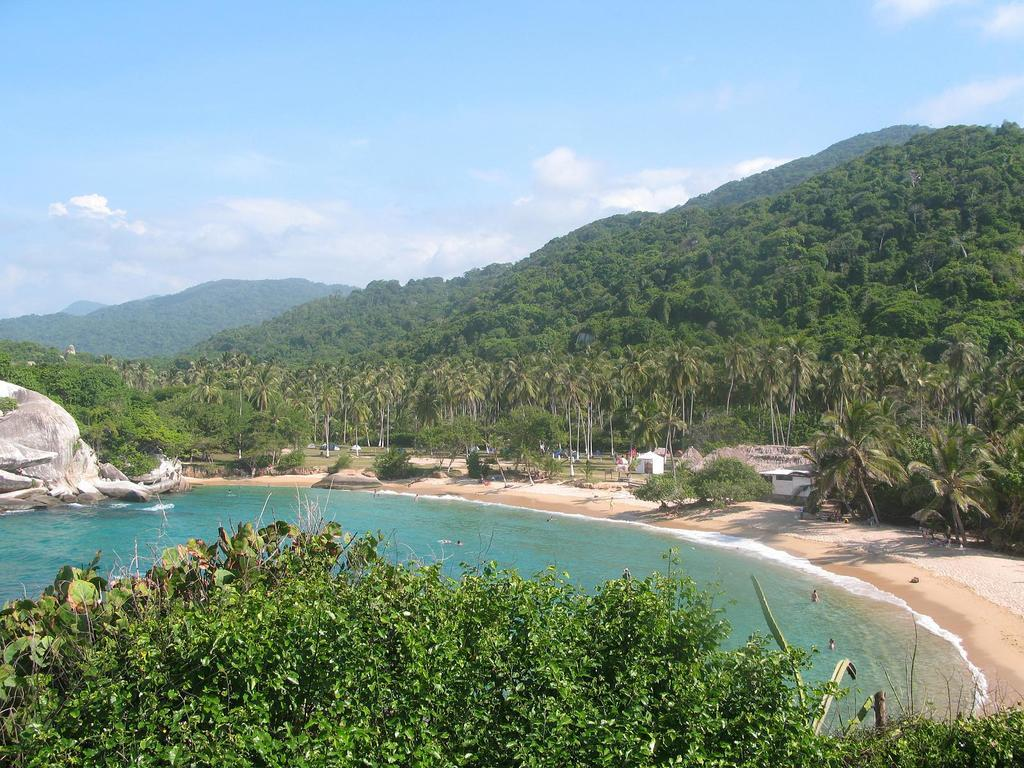What type of natural elements can be seen in the image? There are trees and water visible in the image. What type of structures can be seen in the background of the image? There are sheds and mountains in the background of the image. What is visible in the sky in the image? The sky is visible in the background of the image, and clouds are present. What type of terrain is visible in the background of the image? Rocks are present in the background of the image. Can you read the letter that is floating on the water in the image? There is no letter floating on the water in the image. How many boats can be seen sailing in the water in the image? There are no boats visible in the image. 